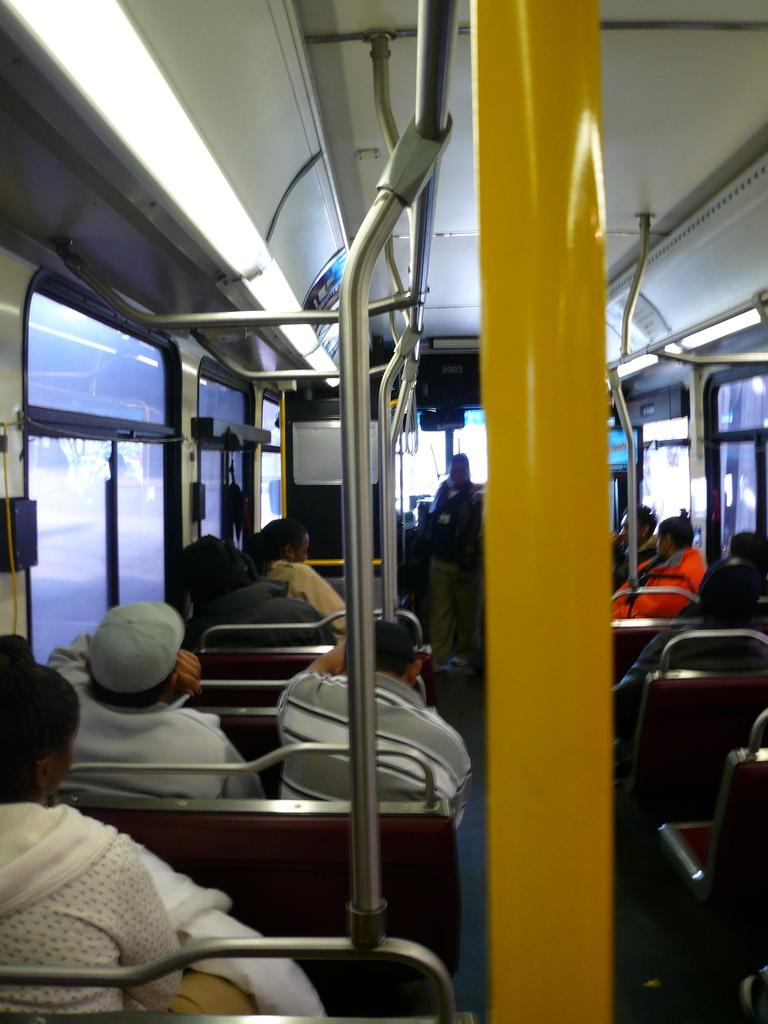Where was the image taken? The image was taken inside a bus. What are the passengers doing in the image? The passengers are sitting on the seats. What additional feature can be seen beside some seats? There are rods attached beside some seats. How old is the boy sitting in the middle of the bus? There is no boy present in the image, and therefore no specific age can be determined. 